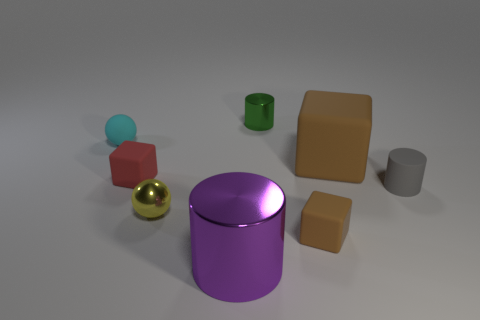Subtract all purple balls. How many brown blocks are left? 2 Subtract all shiny cylinders. How many cylinders are left? 1 Add 2 rubber cylinders. How many objects exist? 10 Subtract all red blocks. How many blocks are left? 2 Subtract 2 cylinders. How many cylinders are left? 1 Add 2 red shiny objects. How many red shiny objects exist? 2 Subtract 1 red cubes. How many objects are left? 7 Subtract all cubes. How many objects are left? 5 Subtract all yellow spheres. Subtract all cyan blocks. How many spheres are left? 1 Subtract all large metal cylinders. Subtract all tiny shiny objects. How many objects are left? 5 